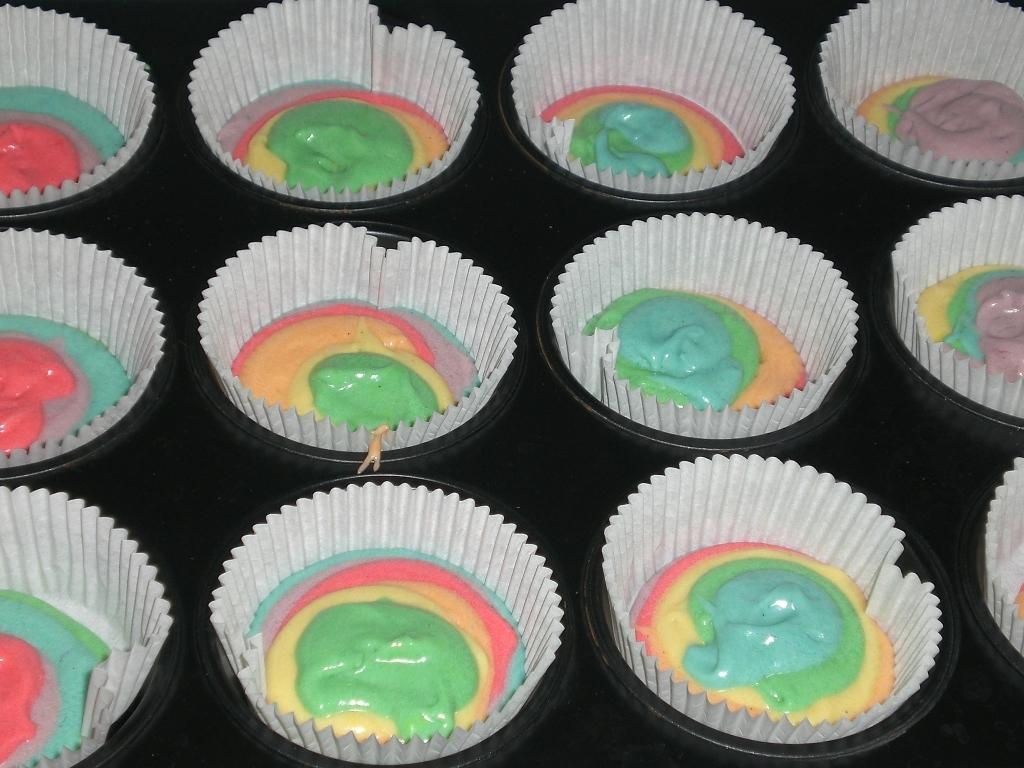What objects are present in the image? There are bowls in the image. What is inside the bowls? The bowls contain wrappers and creams. What type of haircut is visible on the stone in the image? There is no hair or stone present in the image; it only features bowls containing wrappers and creams. 